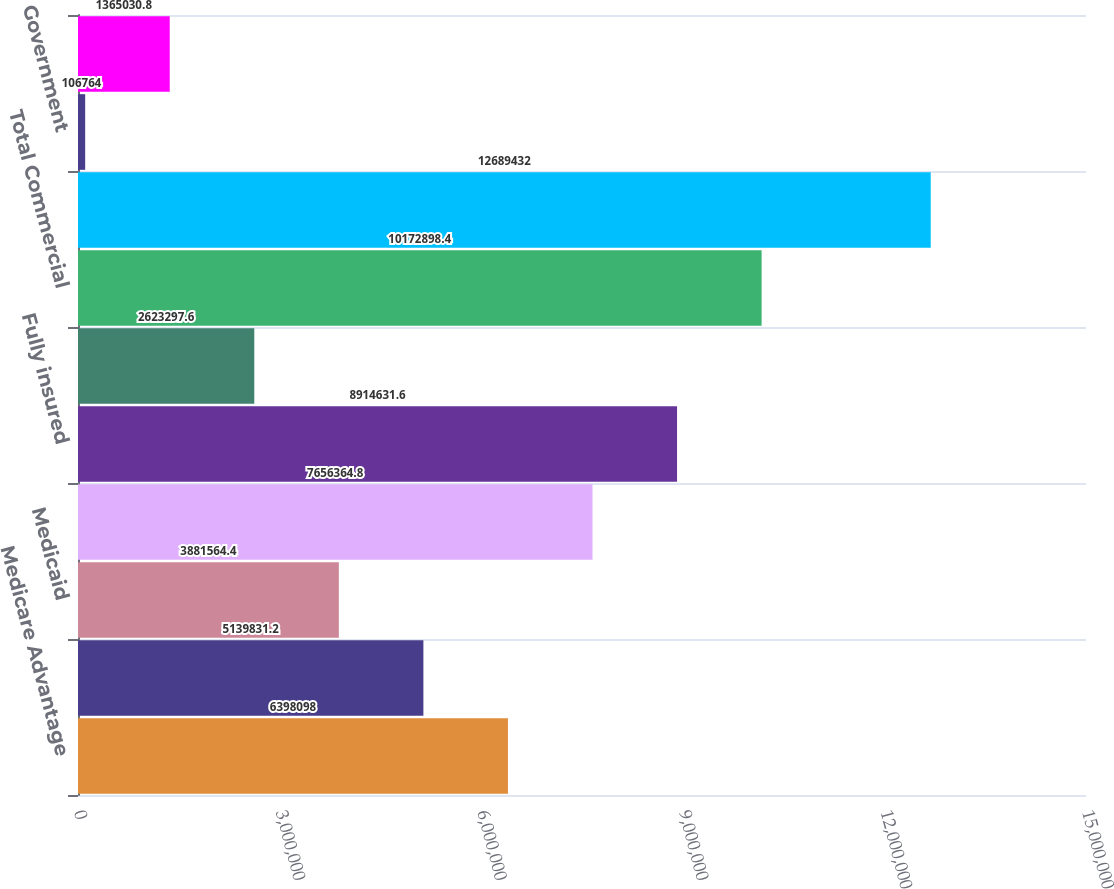<chart> <loc_0><loc_0><loc_500><loc_500><bar_chart><fcel>Medicare Advantage<fcel>TRICARE<fcel>Medicaid<fcel>Total Government<fcel>Fully insured<fcel>Specialty<fcel>Total Commercial<fcel>Total<fcel>Government<fcel>Commercial<nl><fcel>6.3981e+06<fcel>5.13983e+06<fcel>3.88156e+06<fcel>7.65636e+06<fcel>8.91463e+06<fcel>2.6233e+06<fcel>1.01729e+07<fcel>1.26894e+07<fcel>106764<fcel>1.36503e+06<nl></chart> 